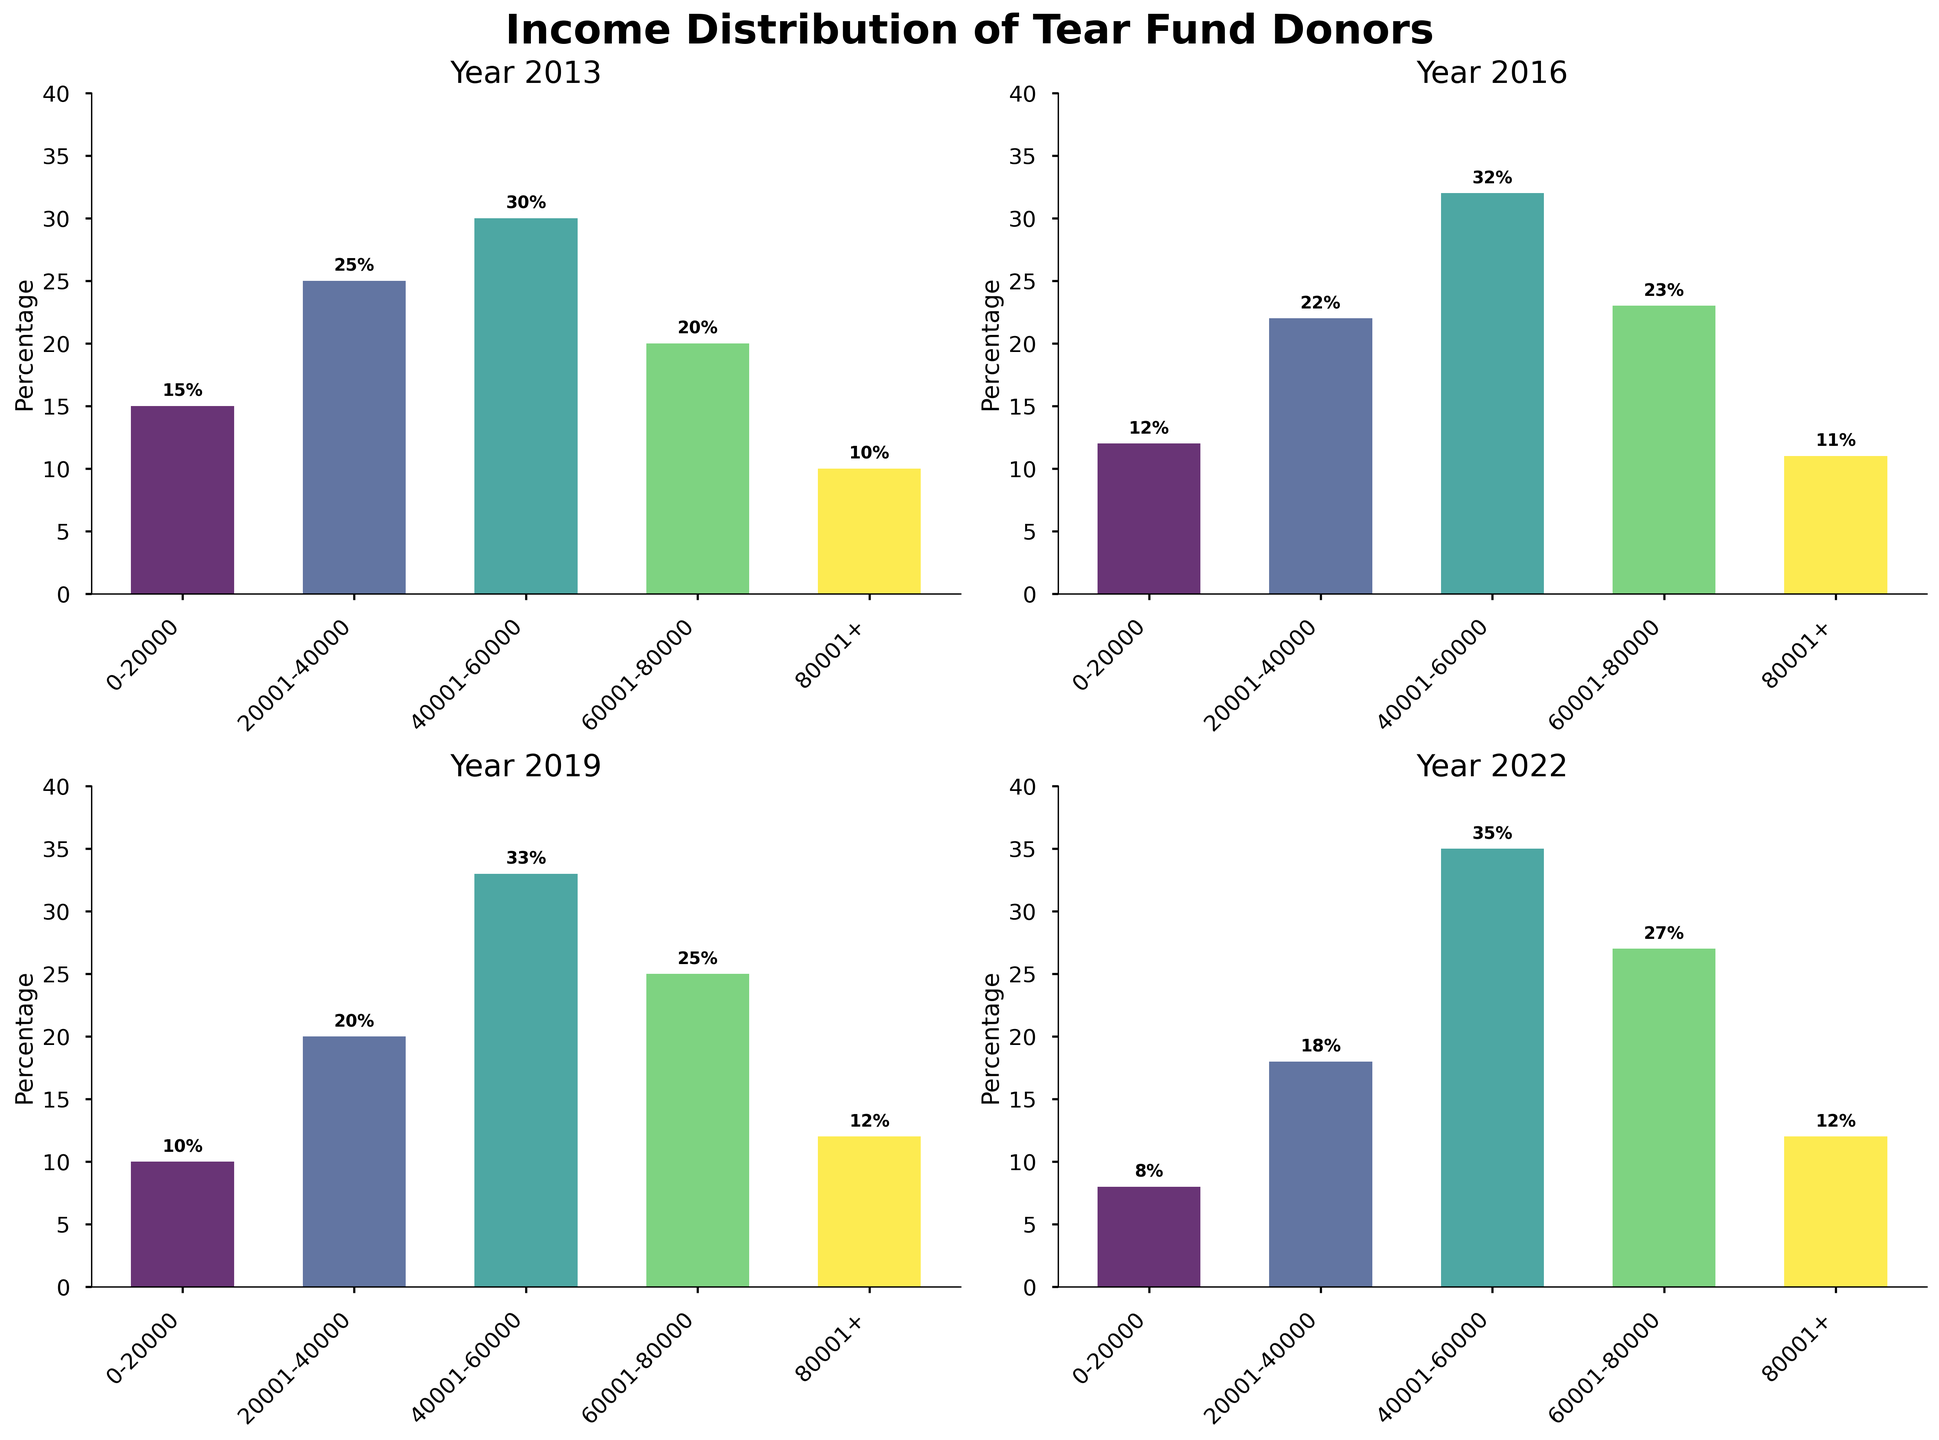What is the title of the figure? The title can be found at the top of the figure in bold and large font. It provides an overview of what the entire figure represents.
Answer: Income Distribution of Tear Fund Donors How does the income distribution for the range $0-20000 change from 2013 to 2022? Compare the percentages for the $0-20000 income range in each subplot (2013, 2016, 2019, and 2022) to observe the change. The percentage decreases from 15% in 2013 to 8% in 2022.
Answer: Decreases from 15% to 8% Which year had the highest percentage of donors in the $40001-60000 income range? Examine each subplot to find the bar representing the $40001-60000 income range and identify the year with the highest percentage. 2022 has the highest percentage at 35%.
Answer: 2022 Compare the percentage of donors in the $60001-80000 income range between 2019 and 2022. Which year had a higher percentage? Look at the percentages for the $60001-80000 range in the 2019 and 2022 subplots. 2022 has a higher percentage at 27%, compared to 25% in 2019.
Answer: 2022 What is the overall trend in the percentage of donors in the $80001+ income range from 2013 to 2022? Track the percentages for the $80001+ income range across all subplots (2013, 2016, 2019, and 2022). The percentage slightly increased from 10% in 2013 to 12% in 2022.
Answer: Slightly increased In which year did the $20001-40000 income range have the lowest percentage of donors? Compare the $20001-40000 bars in each year's subplot to determine the year with the lowest percentage. The lowest percentage is in 2022 at 18%.
Answer: 2022 Considering all income ranges, which income range shows the most consistent percentage of donors across all years? Identify which income range has the least variation in percentage across 2013, 2016, 2019, and 2022. The most consistent is the $80001+ range, varying only from 10% to 12%.
Answer: $80001+ range What is the combined percentage of donors in the $20001-40000 and $60001-80000 income ranges for the year 2016? Add the percentages for the $20001-40000 and $60001-80000 ranges in the 2016 subplot: 22% + 23%. The combined percentage is 45%.
Answer: 45% Which income range saw an increase in the donor percentage between 2016 and 2019? Compare the percentages for each income range between 2016 and 2019 and identify any increases. The $40001-60000 and the $60001-80000 ranges both saw increases (32% to 33% and 23% to 25% respectively).
Answer: $40001-60000 and $60001-80000 How has the percentage of donors in the income range $40001-60000 changed over the past decade? Track the percentage changes in the $40001-60000 income range across the years 2013, 2016, 2019, and 2022. The percentage increased from 30% in 2013 to 35% in 2022.
Answer: Increased from 30% to 35% 